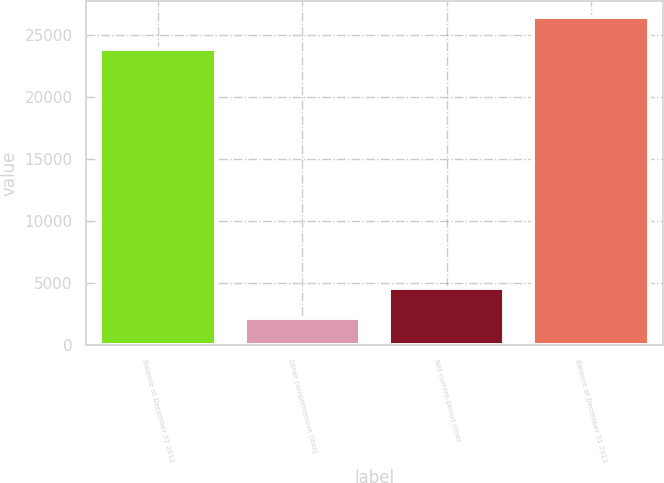<chart> <loc_0><loc_0><loc_500><loc_500><bar_chart><fcel>Balance at December 31 2012<fcel>Other comprehensive (loss)<fcel>Net current-period other<fcel>Balance at December 31 2013<nl><fcel>23861<fcel>2237<fcel>4656<fcel>26427<nl></chart> 